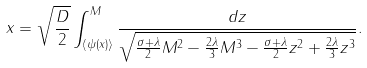Convert formula to latex. <formula><loc_0><loc_0><loc_500><loc_500>x = \sqrt { \frac { D } { 2 } } \int _ { \langle \psi ( x ) \rangle } ^ { M } \frac { d z } { \sqrt { \frac { \sigma + \lambda } { 2 } M ^ { 2 } - \frac { 2 \lambda } { 3 } M ^ { 3 } - \frac { \sigma + \lambda } { 2 } z ^ { 2 } + \frac { 2 \lambda } { 3 } z ^ { 3 } } } .</formula> 